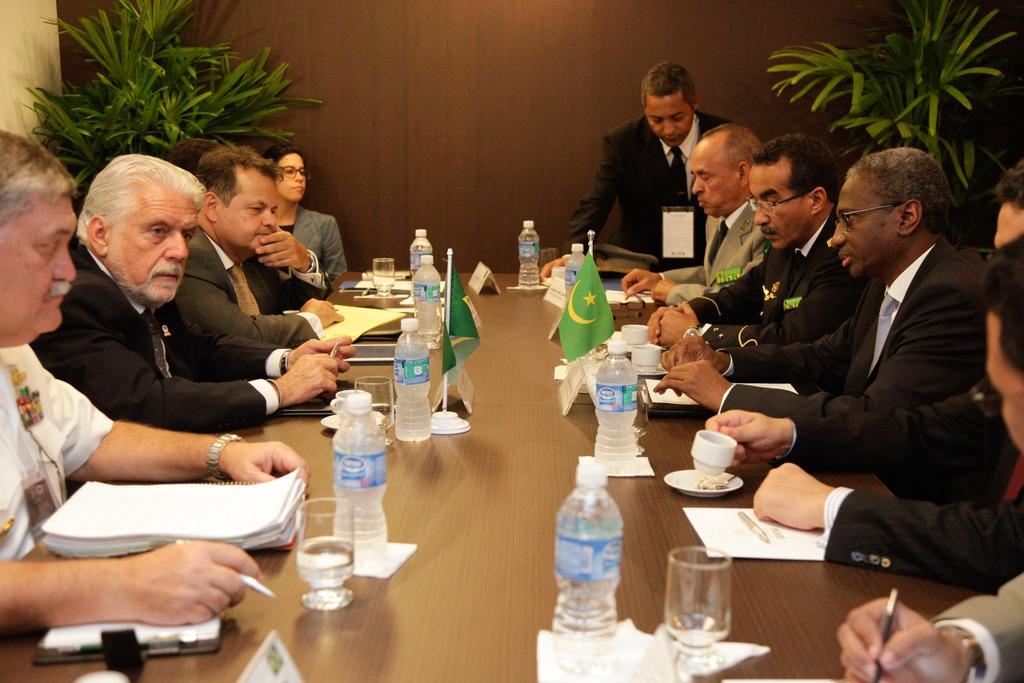Please provide a concise description of this image. In the center of the image there is a table. There are bottles, glasses, papers, pins and flags placed on the table. We can see people sitting around the table. In the background there are plants and wall. 